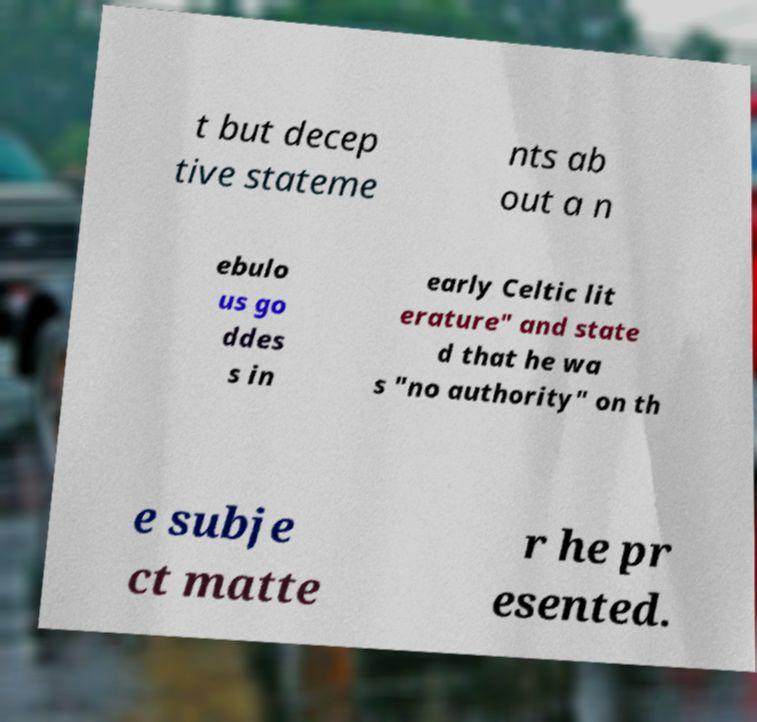For documentation purposes, I need the text within this image transcribed. Could you provide that? t but decep tive stateme nts ab out a n ebulo us go ddes s in early Celtic lit erature" and state d that he wa s "no authority" on th e subje ct matte r he pr esented. 